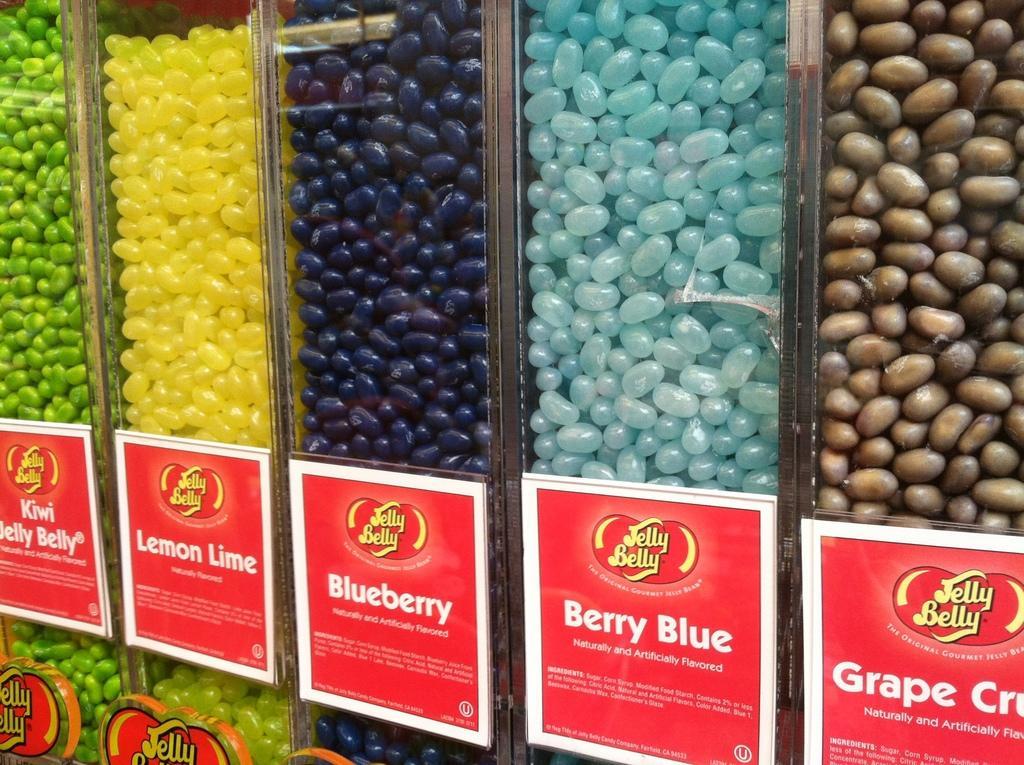Please provide a concise description of this image. In this image we can see some food items in the jars, also we can see some boards on the jars with text on them. 